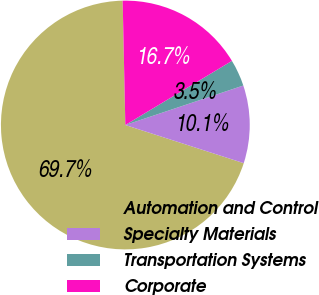Convert chart. <chart><loc_0><loc_0><loc_500><loc_500><pie_chart><fcel>Automation and Control<fcel>Specialty Materials<fcel>Transportation Systems<fcel>Corporate<nl><fcel>69.69%<fcel>10.1%<fcel>3.48%<fcel>16.72%<nl></chart> 